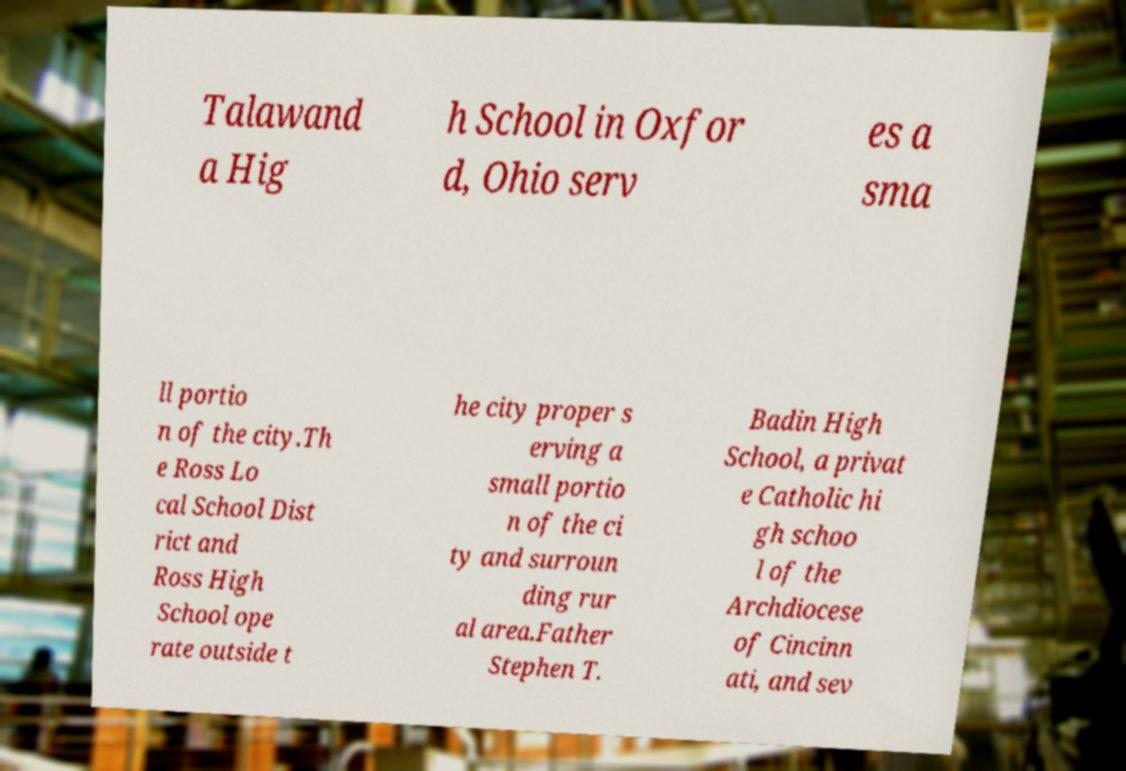Please read and relay the text visible in this image. What does it say? Talawand a Hig h School in Oxfor d, Ohio serv es a sma ll portio n of the city.Th e Ross Lo cal School Dist rict and Ross High School ope rate outside t he city proper s erving a small portio n of the ci ty and surroun ding rur al area.Father Stephen T. Badin High School, a privat e Catholic hi gh schoo l of the Archdiocese of Cincinn ati, and sev 